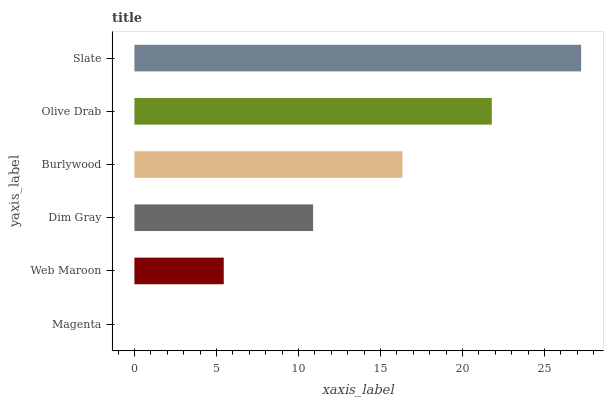Is Magenta the minimum?
Answer yes or no. Yes. Is Slate the maximum?
Answer yes or no. Yes. Is Web Maroon the minimum?
Answer yes or no. No. Is Web Maroon the maximum?
Answer yes or no. No. Is Web Maroon greater than Magenta?
Answer yes or no. Yes. Is Magenta less than Web Maroon?
Answer yes or no. Yes. Is Magenta greater than Web Maroon?
Answer yes or no. No. Is Web Maroon less than Magenta?
Answer yes or no. No. Is Burlywood the high median?
Answer yes or no. Yes. Is Dim Gray the low median?
Answer yes or no. Yes. Is Web Maroon the high median?
Answer yes or no. No. Is Burlywood the low median?
Answer yes or no. No. 